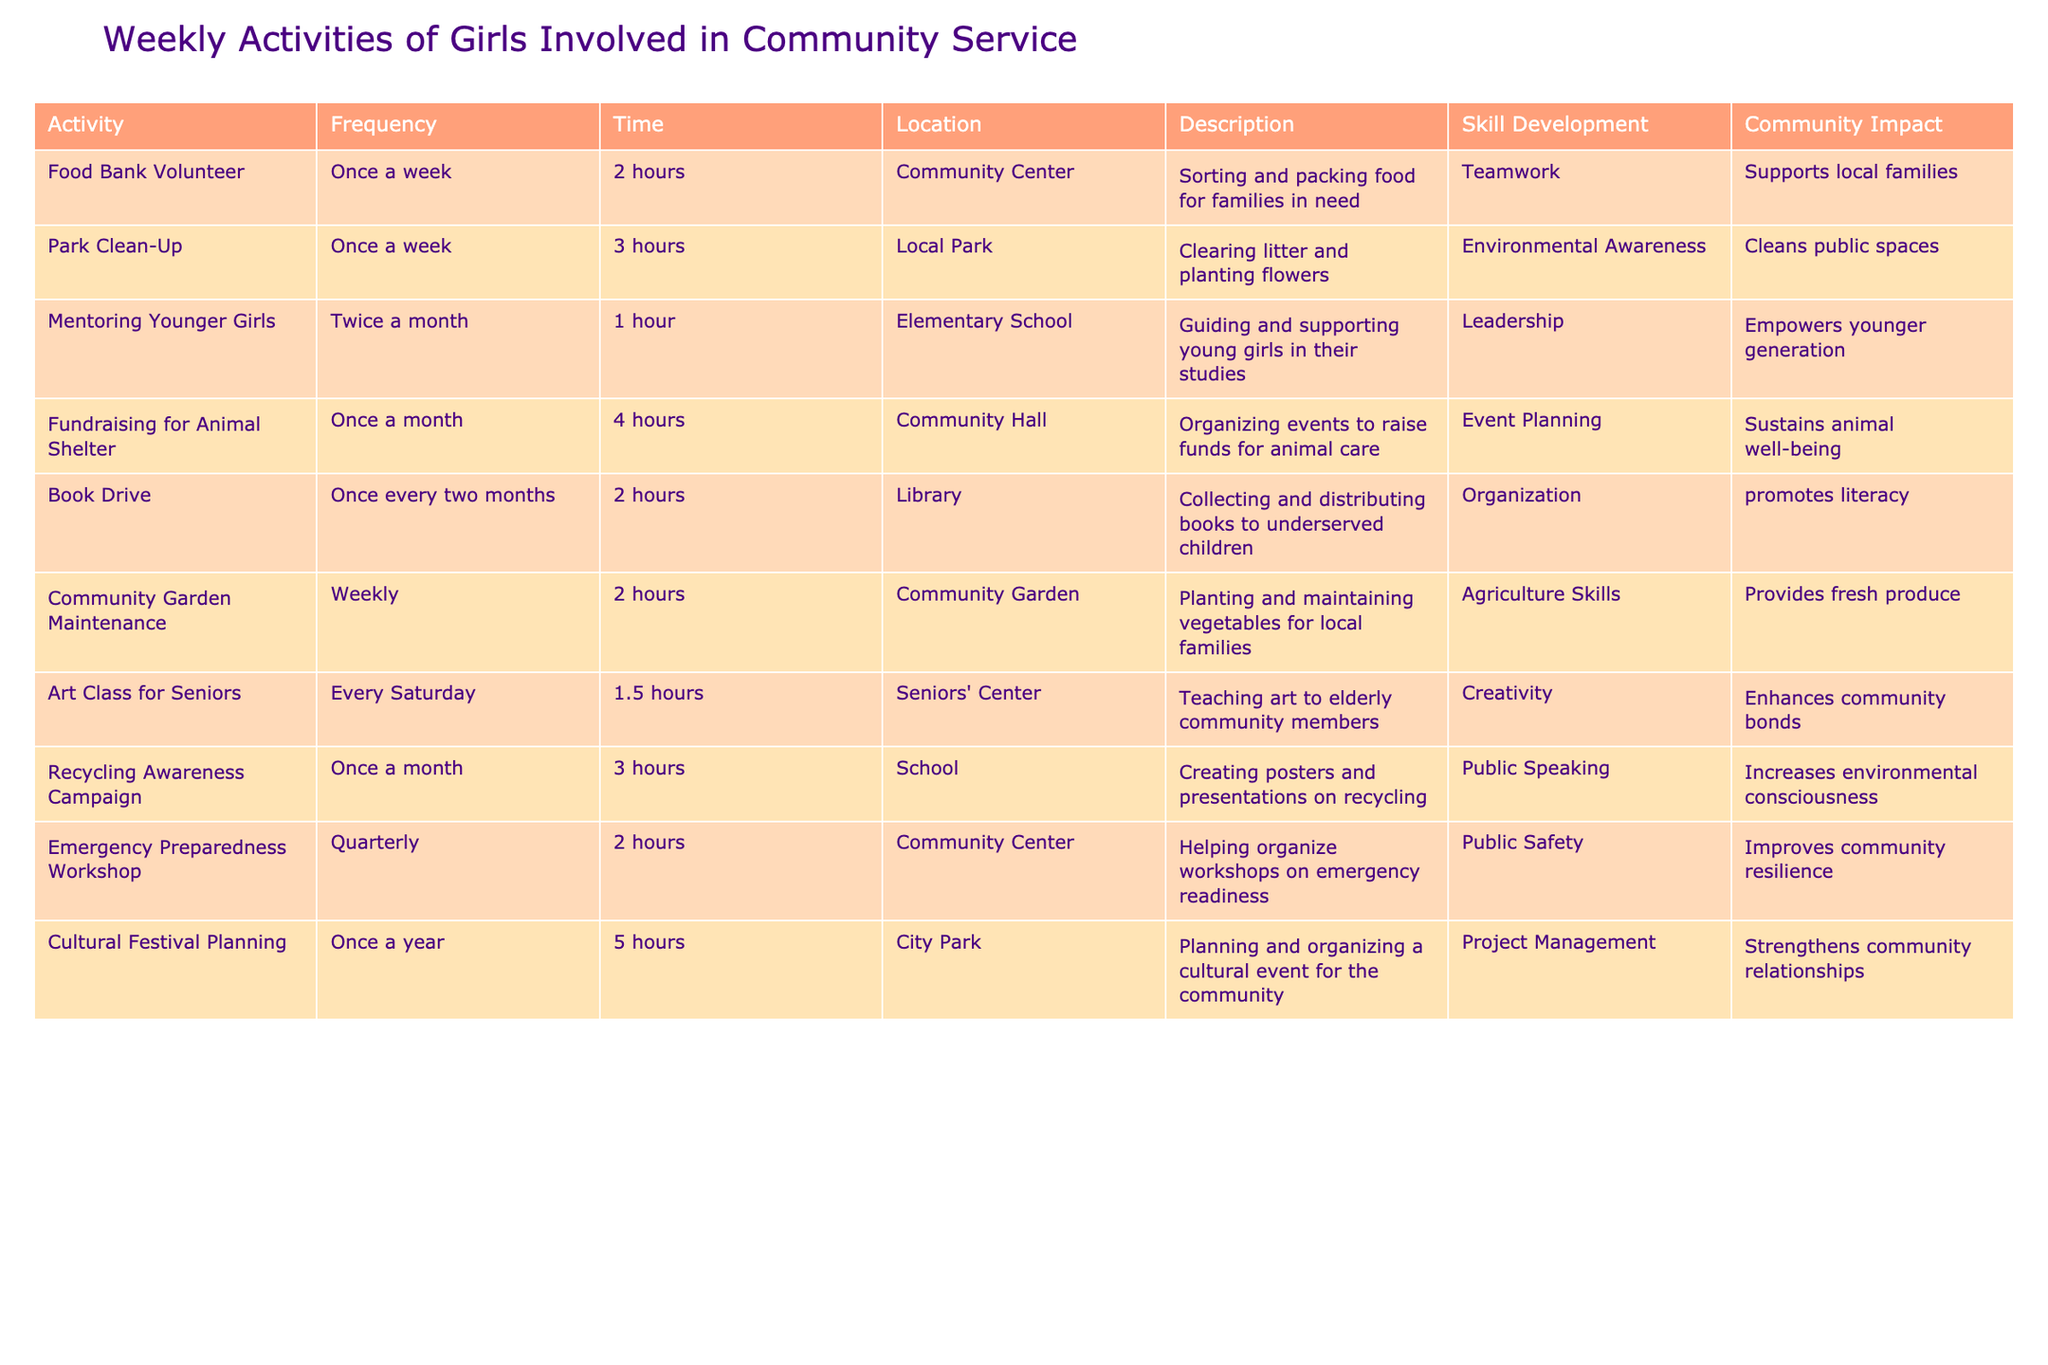What is the frequency of volunteering at the food bank? The table states that the activity "Food Bank Volunteer" has a frequency listed as "Once a week". This indicates how often girls participate in that specific activity.
Answer: Once a week Which activity takes the longest time? By reviewing the time column, we see that "Cultural Festival Planning" is the only activity that takes 5 hours, which is longer than any other listed activities.
Answer: Cultural Festival Planning Are there more activities that occur weekly compared to monthly? By counting the activities that occur weekly, we find 4 (Food Bank Volunteer, Park Clean-Up, Community Garden Maintenance, and Art Class for Seniors). For monthly, there are only 3 (Fundraising for Animal Shelter, Recycling Awareness Campaign). Since 4 is greater than 3, the answer is yes.
Answer: Yes What is the total time spent volunteering for the "Mentoring Younger Girls" activity in a year? This activity occurs twice a month for 1 hour, totaling 2 hours per month. In a year, there are 12 months, so 2 hours/month * 12 months = 24 hours. Therefore, the total time spent volunteering for this activity in a year is 24 hours.
Answer: 24 hours Which activity focuses on sustainability? By examining the description column, "Recycling Awareness Campaign" clearly focuses on sustainability as it involves creating materials that promote recycling to increase environmental consciousness.
Answer: Recycling Awareness Campaign How many different locations are used for the community service activities? We can identify the locations listed: Community Center, Local Park, Elementary School, Community Hall, Library, Community Garden, Seniors' Center, and School. Counting these gives us a total of 8 distinct locations used for the activities.
Answer: 8 locations Is the "Emergency Preparedness Workshop" held monthly? The table specifies that this workshop occurs quarterly, meaning it takes place once every three months, not monthly. Therefore, the answer is no.
Answer: No Which two activities require leadership skills? The activities "Mentoring Younger Girls" and "Emergency Preparedness Workshop" both involve elements of leadership, as mentoring requires guiding others and organizing a workshop is a leadership task.
Answer: Mentoring Younger Girls and Emergency Preparedness Workshop 